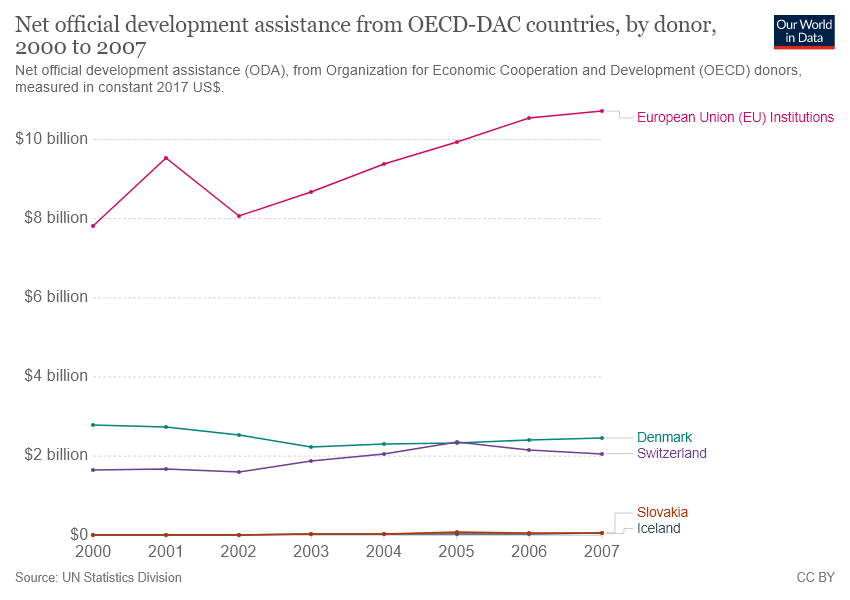Is the sum of official development assistance(ODA) for Denmark and Switzerland in 2000 greater than $4 billion?
 No 